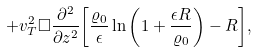<formula> <loc_0><loc_0><loc_500><loc_500>+ v _ { T } ^ { 2 } \Box { \frac { \partial ^ { 2 } } { \partial z ^ { 2 } } } { \left [ { \frac { \varrho _ { 0 } } { \epsilon } } \ln { \left ( 1 + { \frac { \epsilon R } { \varrho _ { 0 } } } \right ) } - R \right ] } ,</formula> 